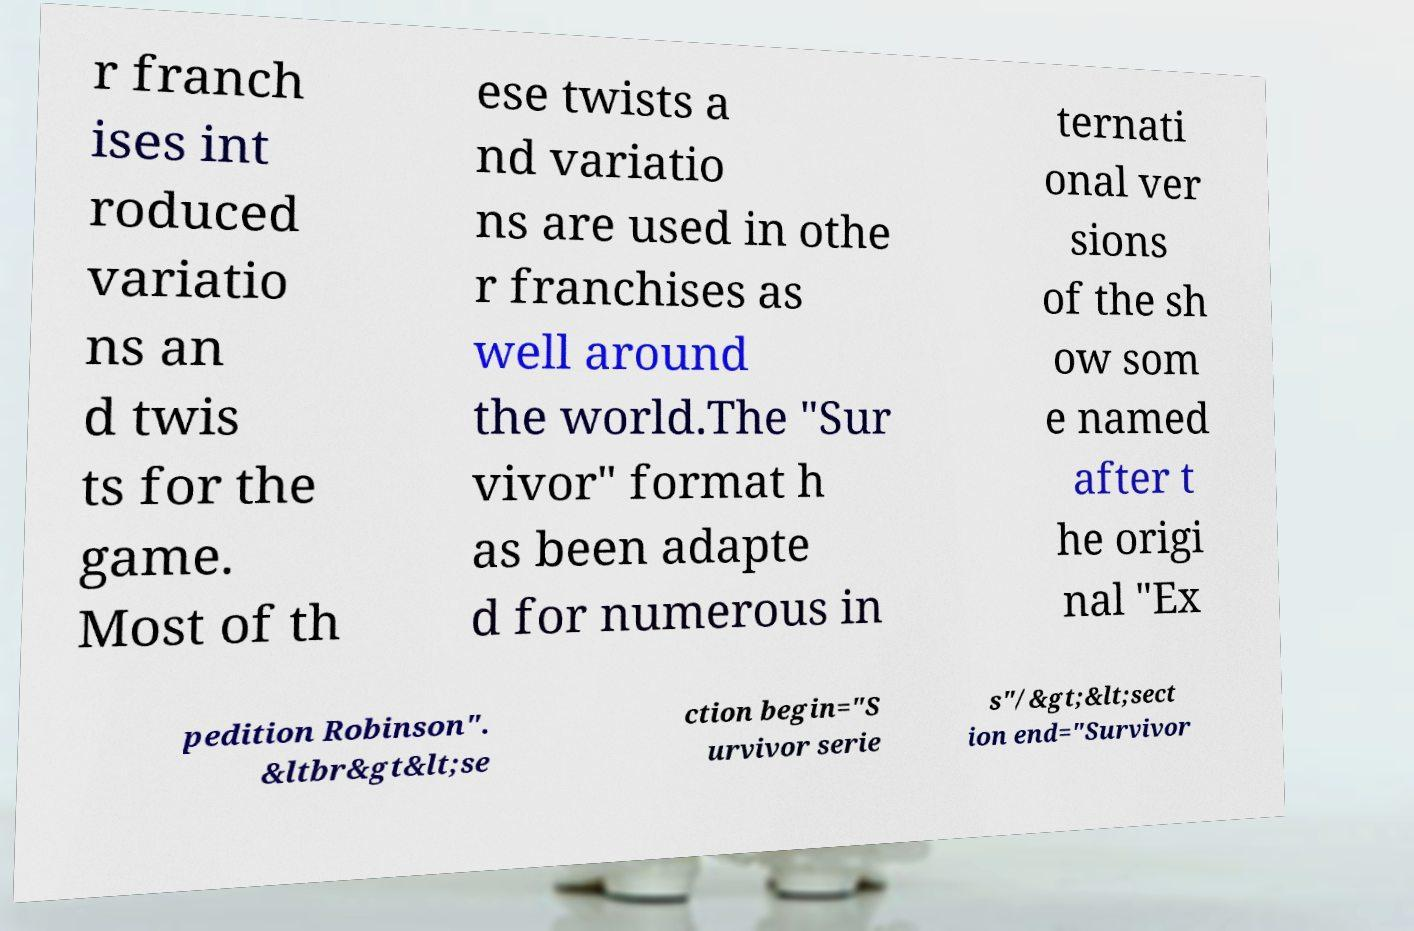For documentation purposes, I need the text within this image transcribed. Could you provide that? r franch ises int roduced variatio ns an d twis ts for the game. Most of th ese twists a nd variatio ns are used in othe r franchises as well around the world.The "Sur vivor" format h as been adapte d for numerous in ternati onal ver sions of the sh ow som e named after t he origi nal "Ex pedition Robinson". &ltbr&gt&lt;se ction begin="S urvivor serie s"/&gt;&lt;sect ion end="Survivor 